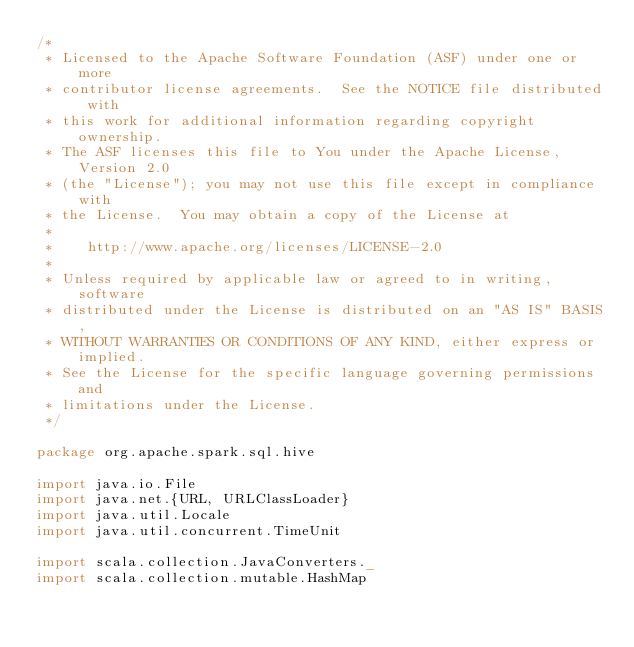<code> <loc_0><loc_0><loc_500><loc_500><_Scala_>/*
 * Licensed to the Apache Software Foundation (ASF) under one or more
 * contributor license agreements.  See the NOTICE file distributed with
 * this work for additional information regarding copyright ownership.
 * The ASF licenses this file to You under the Apache License, Version 2.0
 * (the "License"); you may not use this file except in compliance with
 * the License.  You may obtain a copy of the License at
 *
 *    http://www.apache.org/licenses/LICENSE-2.0
 *
 * Unless required by applicable law or agreed to in writing, software
 * distributed under the License is distributed on an "AS IS" BASIS,
 * WITHOUT WARRANTIES OR CONDITIONS OF ANY KIND, either express or implied.
 * See the License for the specific language governing permissions and
 * limitations under the License.
 */

package org.apache.spark.sql.hive

import java.io.File
import java.net.{URL, URLClassLoader}
import java.util.Locale
import java.util.concurrent.TimeUnit

import scala.collection.JavaConverters._
import scala.collection.mutable.HashMap</code> 